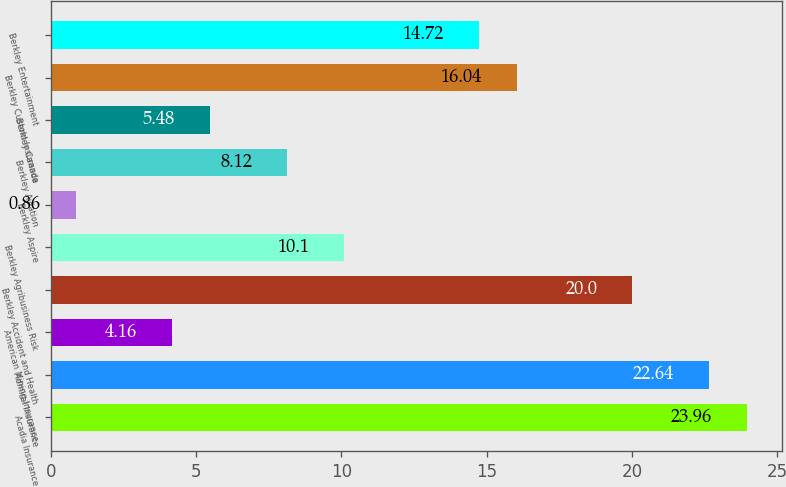<chart> <loc_0><loc_0><loc_500><loc_500><bar_chart><fcel>Acadia Insurance<fcel>Admiral Insurance<fcel>American Mining Insurance<fcel>Berkley Accident and Health<fcel>Berkley Agribusiness Risk<fcel>Berkley Aspire<fcel>Berkley Aviation<fcel>Berkley Canada<fcel>Berkley Custom Insurance<fcel>Berkley Entertainment<nl><fcel>23.96<fcel>22.64<fcel>4.16<fcel>20<fcel>10.1<fcel>0.86<fcel>8.12<fcel>5.48<fcel>16.04<fcel>14.72<nl></chart> 